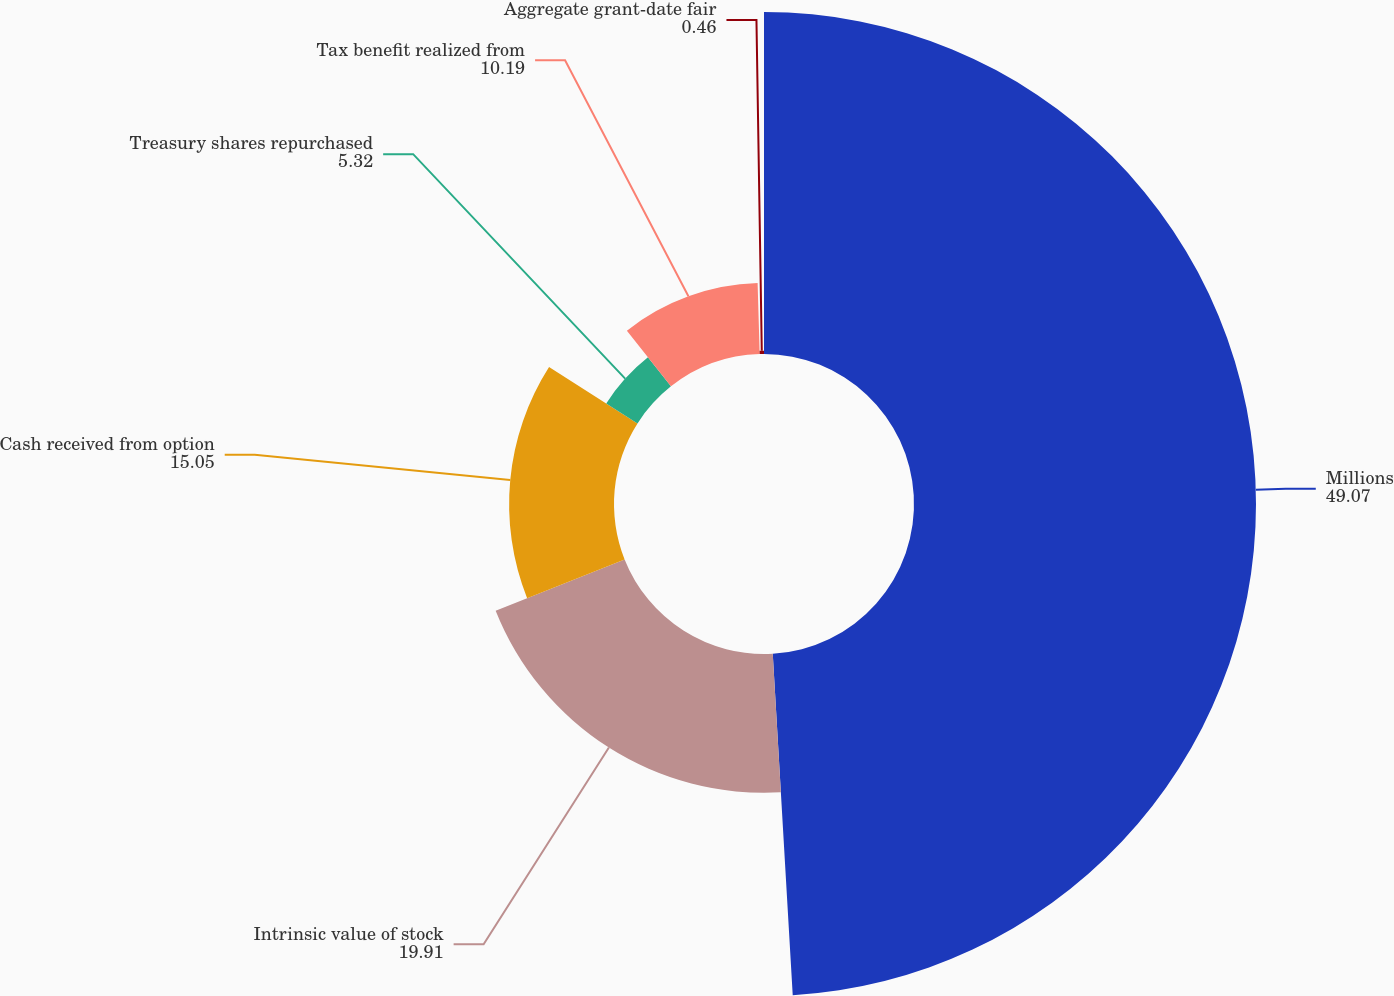Convert chart to OTSL. <chart><loc_0><loc_0><loc_500><loc_500><pie_chart><fcel>Millions<fcel>Intrinsic value of stock<fcel>Cash received from option<fcel>Treasury shares repurchased<fcel>Tax benefit realized from<fcel>Aggregate grant-date fair<nl><fcel>49.07%<fcel>19.91%<fcel>15.05%<fcel>5.32%<fcel>10.19%<fcel>0.46%<nl></chart> 